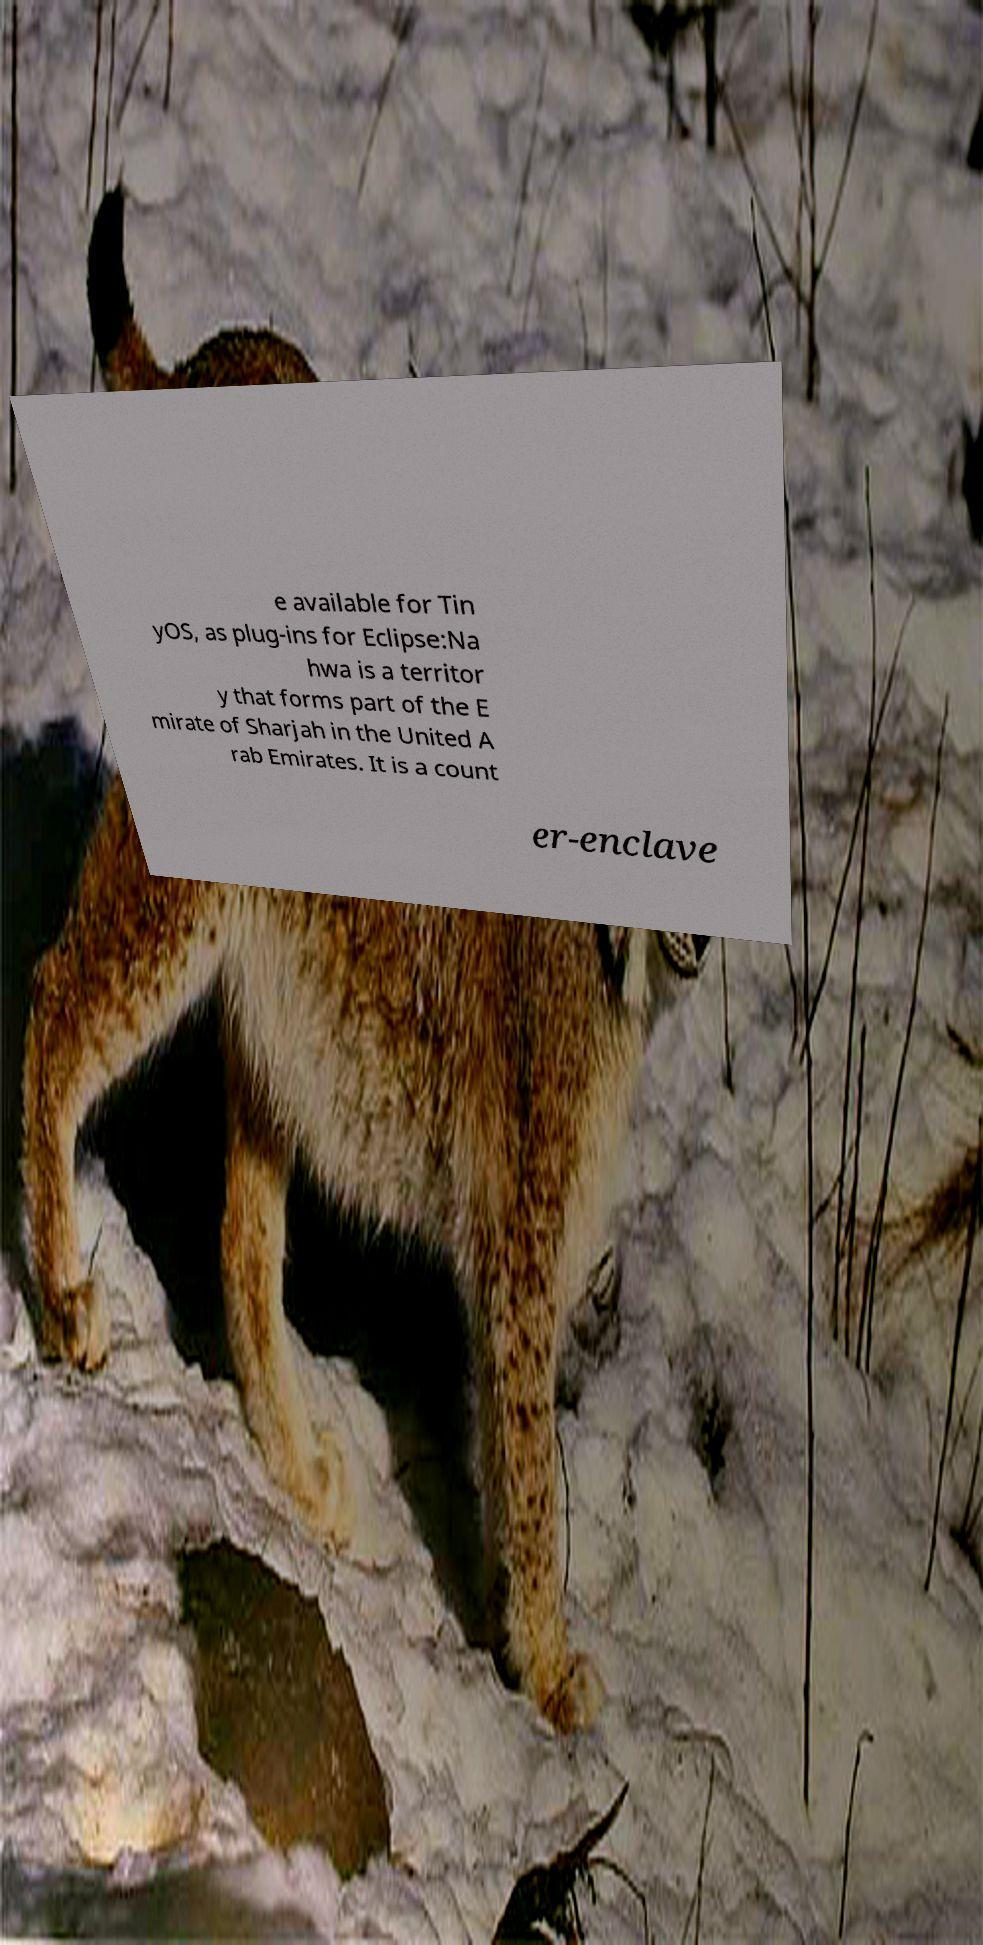What messages or text are displayed in this image? I need them in a readable, typed format. e available for Tin yOS, as plug-ins for Eclipse:Na hwa is a territor y that forms part of the E mirate of Sharjah in the United A rab Emirates. It is a count er-enclave 